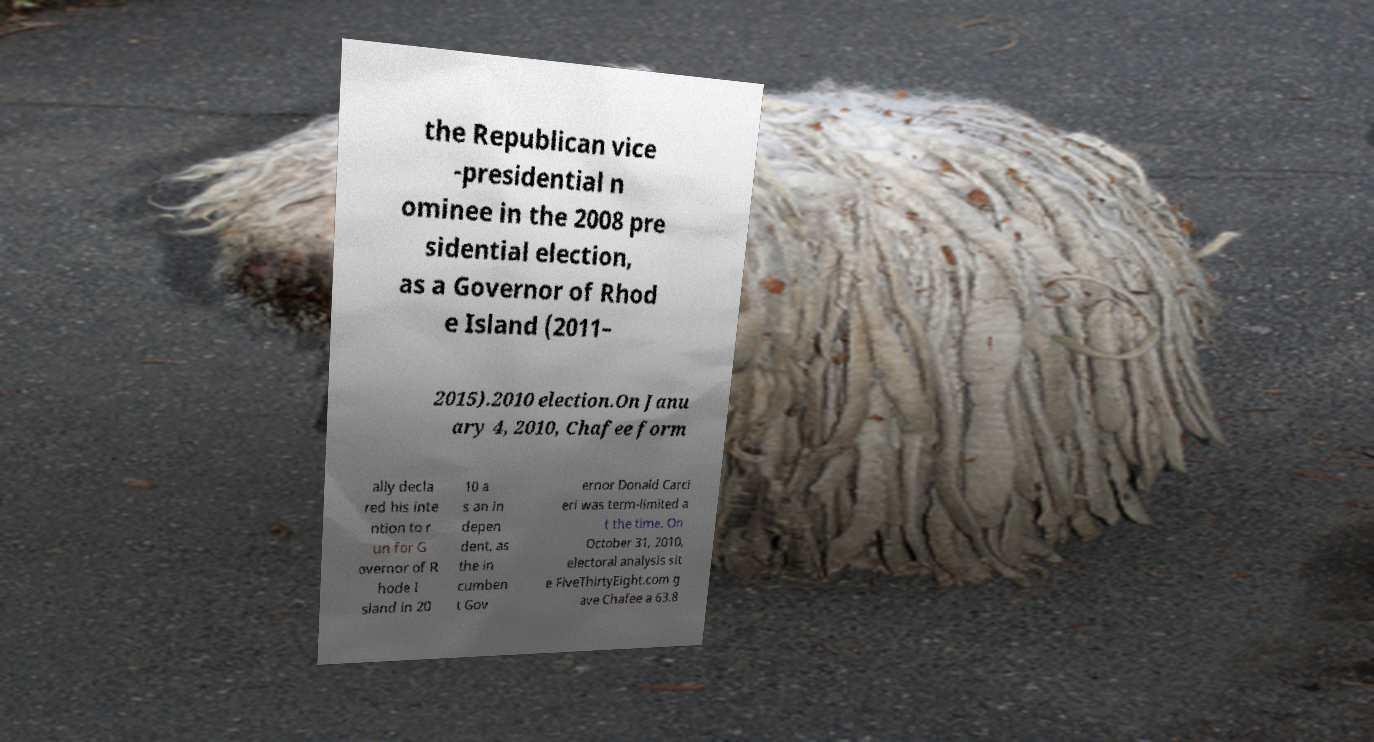Could you extract and type out the text from this image? the Republican vice -presidential n ominee in the 2008 pre sidential election, as a Governor of Rhod e Island (2011– 2015).2010 election.On Janu ary 4, 2010, Chafee form ally decla red his inte ntion to r un for G overnor of R hode I sland in 20 10 a s an in depen dent, as the in cumben t Gov ernor Donald Carci eri was term-limited a t the time. On October 31, 2010, electoral analysis sit e FiveThirtyEight.com g ave Chafee a 63.8 